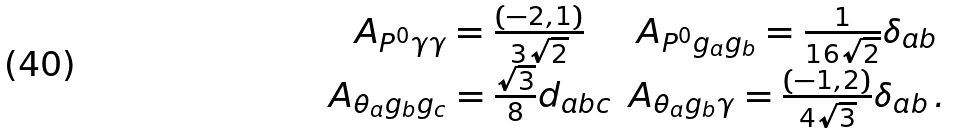Convert formula to latex. <formula><loc_0><loc_0><loc_500><loc_500>\begin{array} { c c } A _ { P ^ { 0 } \gamma \gamma } = \frac { ( - 2 , 1 ) } { 3 \sqrt { 2 } } & A _ { P ^ { 0 } g _ { a } g _ { b } } = \frac { 1 } { 1 6 \sqrt { 2 } } \delta _ { a b } \\ A _ { \theta _ { a } g _ { b } g _ { c } } = \frac { \sqrt { 3 } } { 8 } d _ { a b c } & A _ { \theta _ { a } g _ { b } \gamma } = \frac { ( - 1 , 2 ) } { 4 \sqrt { 3 } } \delta _ { a b } \, . \end{array}</formula> 